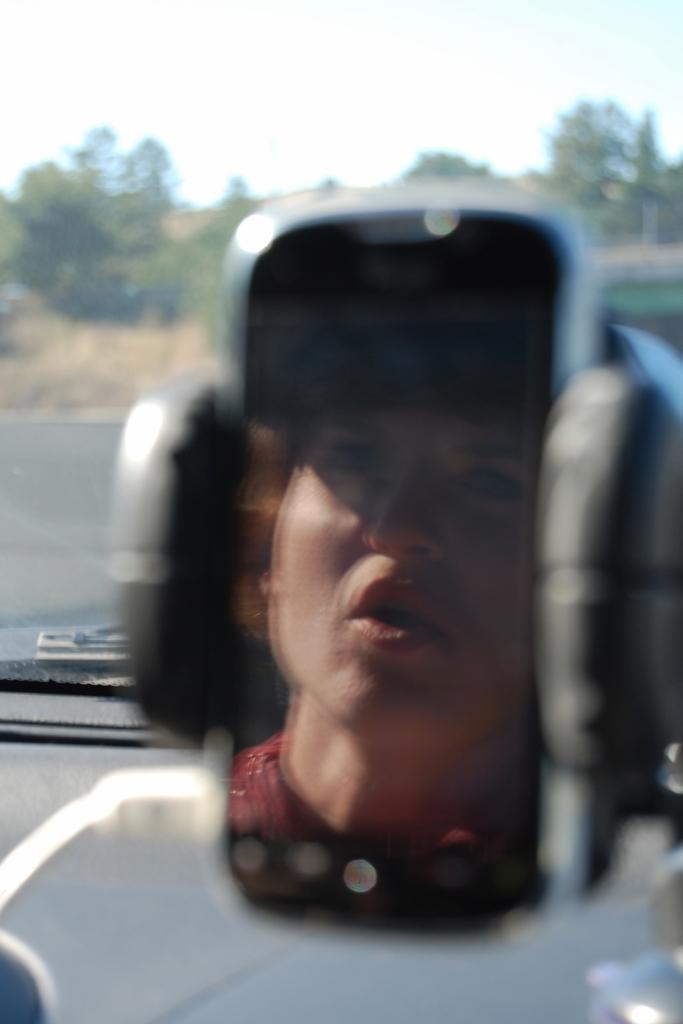Could you give a brief overview of what you see in this image? We can see gadget with stand,in this screen we can see person face. In the background we can see trees and sky. 